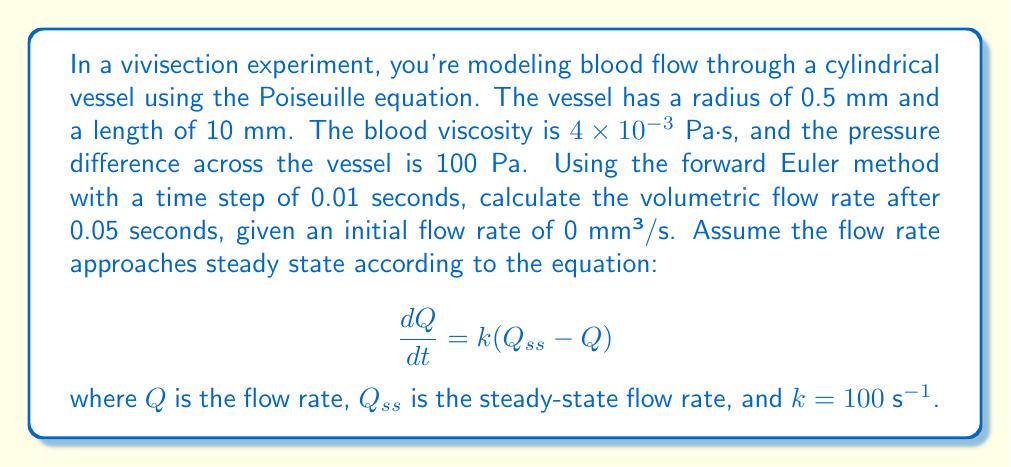Provide a solution to this math problem. To solve this problem, we'll follow these steps:

1) First, calculate the steady-state flow rate $Q_{ss}$ using the Poiseuille equation:

   $$Q_{ss} = \frac{\pi r^4 \Delta P}{8 \mu L}$$

   where $r$ is the radius, $\Delta P$ is the pressure difference, $\mu$ is the viscosity, and $L$ is the length.

   $$Q_{ss} = \frac{\pi (0.5 \times 10^{-3})^4 \times 100}{8 \times 4 \times 10^{-3} \times 10 \times 10^{-3}} = 3.068 \times 10^{-9} \text{ m}^3/\text{s} = 3.068 \text{ mm}^3/\text{s}$$

2) Now, we'll use the forward Euler method to solve the differential equation:

   $$\frac{dQ}{dt} = k(Q_{ss} - Q)$$

   The forward Euler method is given by:

   $$Q_{n+1} = Q_n + \Delta t \cdot f(Q_n)$$

   where $f(Q_n) = k(Q_{ss} - Q_n)$

3) We'll calculate 5 steps with $\Delta t = 0.01$ s:

   Step 1: $Q_1 = 0 + 0.01 \times 100(3.068 - 0) = 3.068$ mm³/s
   Step 2: $Q_2 = 3.068 + 0.01 \times 100(3.068 - 3.068) = 3.068$ mm³/s
   Step 3: $Q_3 = 3.068 + 0.01 \times 100(3.068 - 3.068) = 3.068$ mm³/s
   Step 4: $Q_4 = 3.068 + 0.01 \times 100(3.068 - 3.068) = 3.068$ mm³/s
   Step 5: $Q_5 = 3.068 + 0.01 \times 100(3.068 - 3.068) = 3.068$ mm³/s
Answer: The volumetric flow rate after 0.05 seconds is 3.068 mm³/s. 